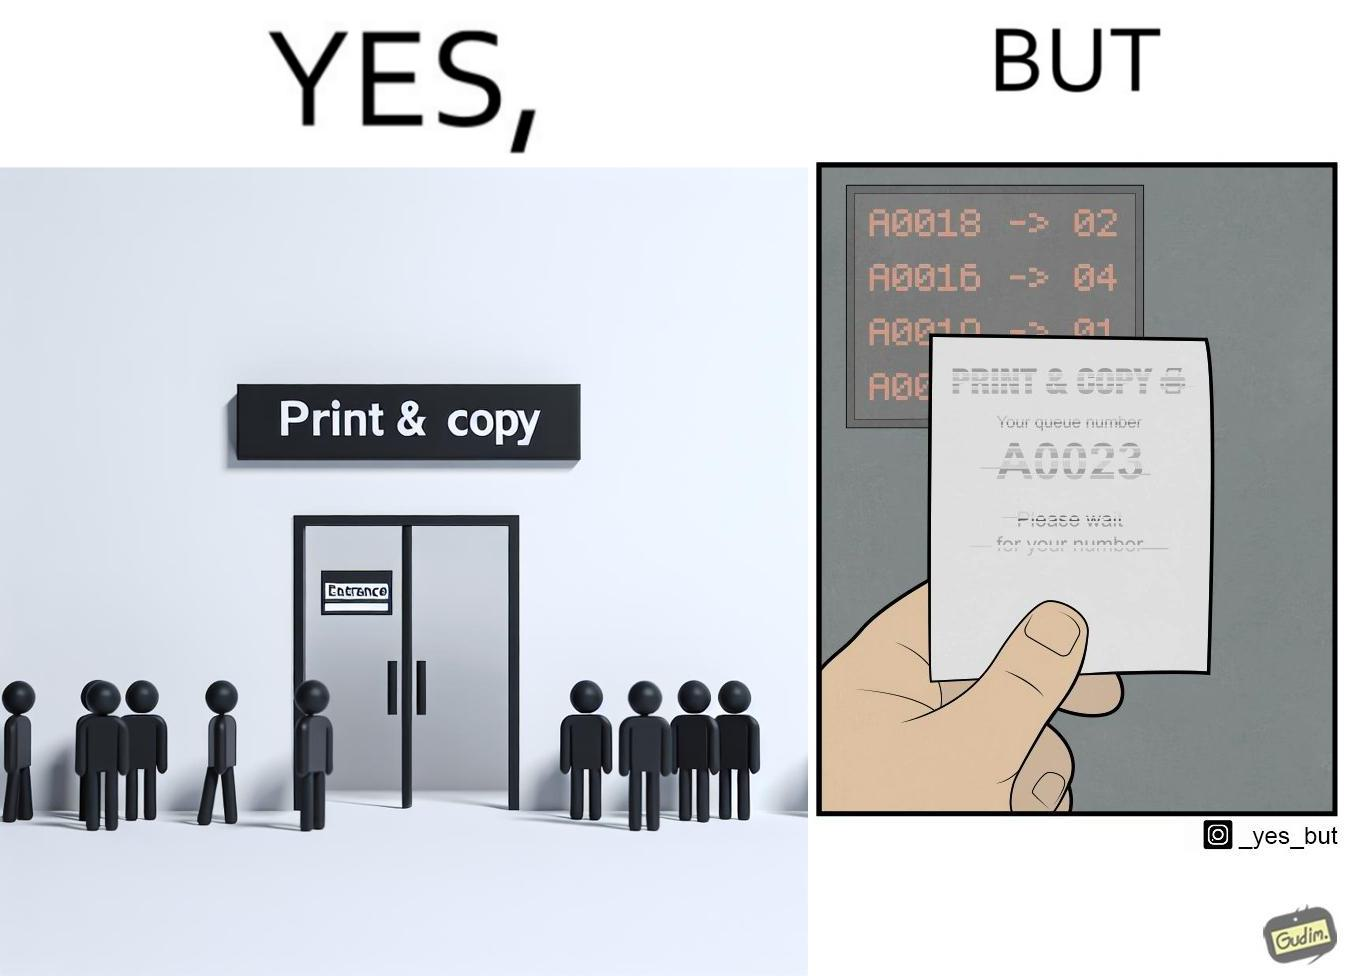What is shown in this image? The image is ironic, as the waiting slip in a "Print & Copy" Centre is printed with insufficient printing ink. 